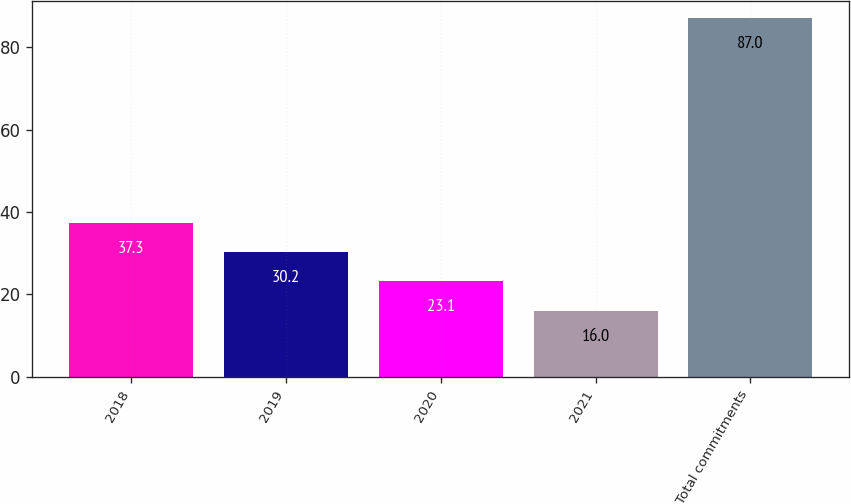Convert chart. <chart><loc_0><loc_0><loc_500><loc_500><bar_chart><fcel>2018<fcel>2019<fcel>2020<fcel>2021<fcel>Total commitments<nl><fcel>37.3<fcel>30.2<fcel>23.1<fcel>16<fcel>87<nl></chart> 